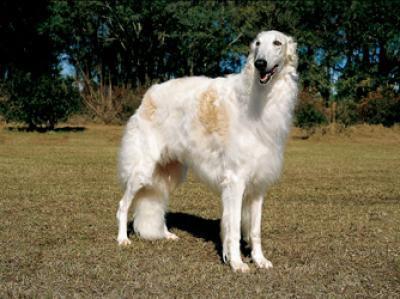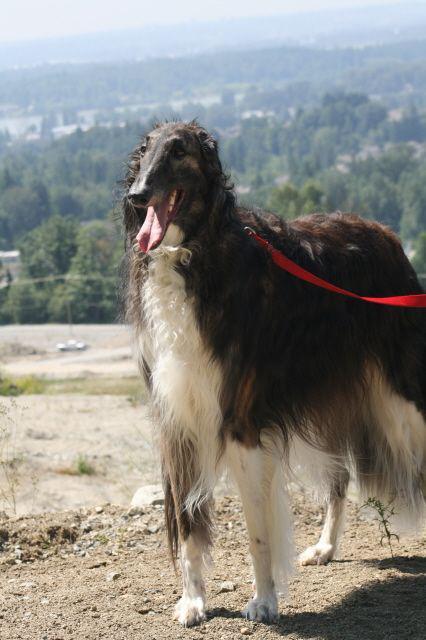The first image is the image on the left, the second image is the image on the right. Examine the images to the left and right. Is the description "One image shows two hounds with similar coloration." accurate? Answer yes or no. No. 